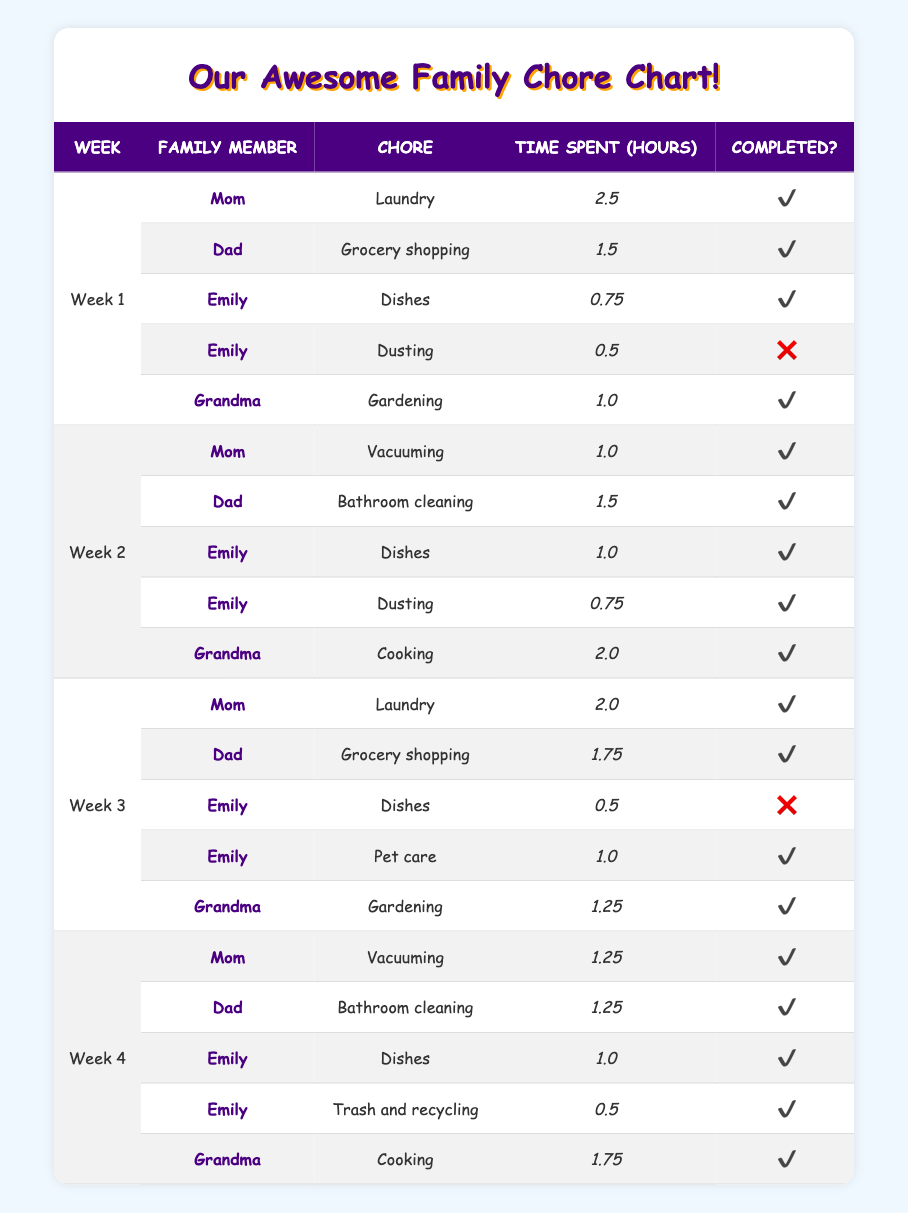What was the total time spent by Emily on chores during week 1? In week 1, Emily completed two chores: Dishes and Dusting. The time spent on Dishes was 0.75 hours and Dusting (not completed) was 0.5 hours, which we still include in the total time. So, total time = 0.75 + 0.5 = 1.25 hours.
Answer: 1.25 hours How many chores did Grandma complete in total? Grandma completed her chores in week 1 (Gardening), week 2 (Cooking), week 3 (Gardening), and week 4 (Cooking). This is a total of 4 completed chores.
Answer: 4 Was the Dishes chore completed every week by Emily? In week 1, Emily completed the Dishes chore. In week 2, she completed the Dishes chore again. However, in week 3, Emily did not complete the Dishes chore. Thus, the answer is no, not every week.
Answer: No What is the average time spent on chores by Dad over the four weeks? Dad completed chores in weeks 1, 2, 3, and 4. The time taken was 1.5 hours in week 1, 1.5 hours in week 2, 1.75 hours in week 3, and 1.25 hours in week 4. The total time spent is 1.5 + 1.5 + 1.75 + 1.25 = 5 hours. The average is 5 hours divided by 4 weeks = 1.25 hours.
Answer: 1.25 hours Which family member spent the most time on chores in week 3? In week 3, the times spent were: Mom - 2 hours, Dad - 1.75 hours, Emily - 0.5 hours (not completed) + 1 hour (completed) = 1 hour, and Grandma - 1.25 hours for Gardening. The maximum time is 2 hours by Mom.
Answer: Mom How many chores did Emily complete in total across the four weeks? Emily completed her Dishes chores in weeks 1, 2, and 4, and the Pet care chore in week 3. The Dusting chores in weeks 1 and 2 were completed, but the one in week 3 was not. Therefore, she completed a total of 4 chores (counting completed Dusting in week 2).
Answer: 4 Was there any week where Grandma did not complete her chores? All Grandma’s assigned chores in week 1 (Gardening), week 2 (Cooking), week 3 (Gardening), and week 4 (Cooking) were completed without any incompletion. Thus, the answer is no.
Answer: No What was the most time spent by a family member on a single chore? The highest time spent on a single chore was by Mom in week 1 with 2.5 hours for Laundry. No other chore exceeds this time, so it's the maximum.
Answer: 2.5 hours 